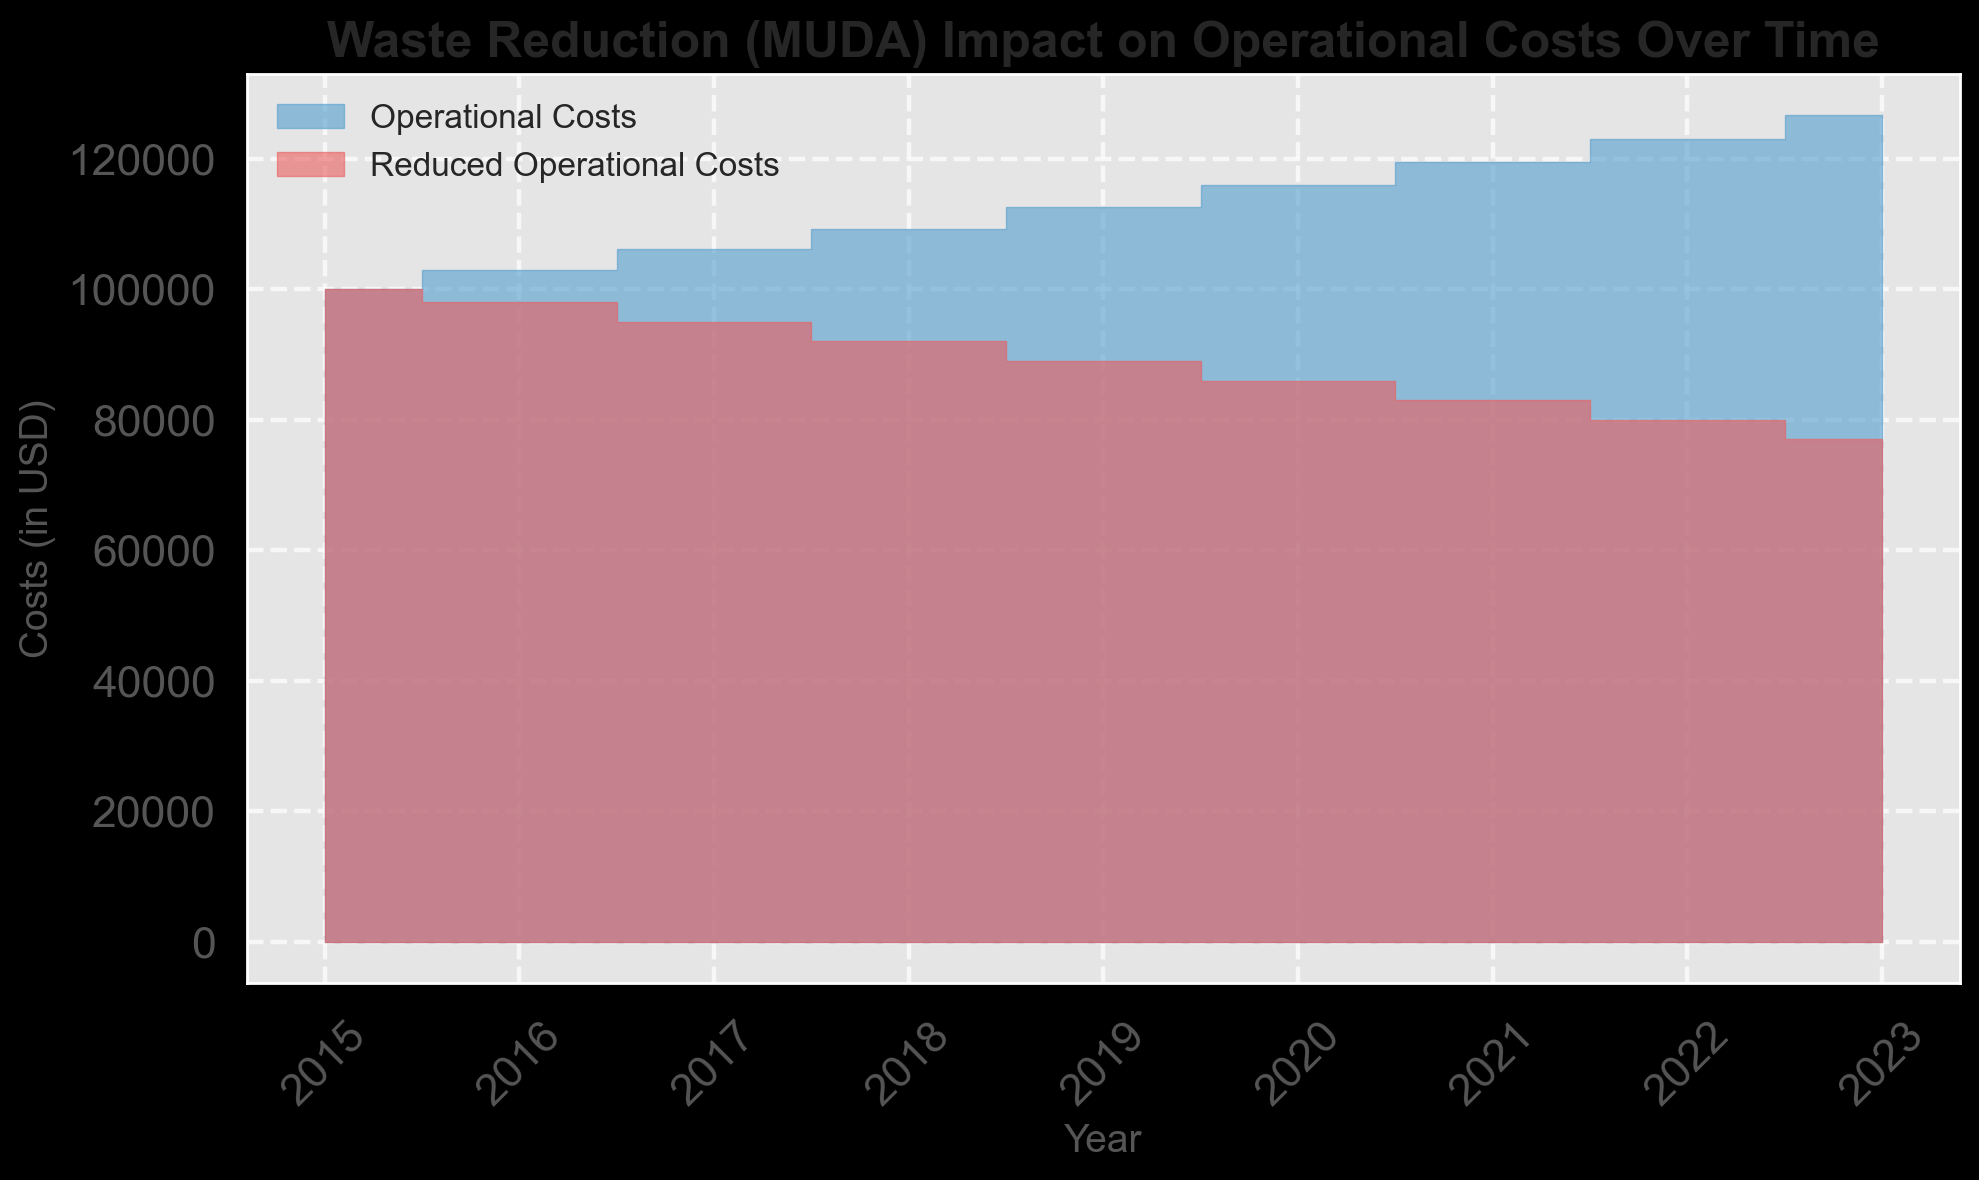What year shows the greatest difference between Operational Costs and Reduced Operational Costs? In the chart, look for the year where the gap between the blue and red areas is the widest. This visual gap represents the difference between the two costs.
Answer: 2023 Between 2015 and 2023, in which year do Operational Costs exceed $110,000? Identify the point where the blue area crosses above the $110,000 mark. Look along the x-axis between 2015 and 2023.
Answer: 2019 During which years do the Reduced Operational Costs trend downward? Observe the red area in the plot and note the years where the height of the red area decreases as time progresses.
Answer: 2016-2023 By how much did the Reduced Operational Costs decrease between 2015 and 2018? Subtract the Reduced Operational Costs in 2018 from those in 2015. The calculation is $100,000 - $92,000, which gives the difference.
Answer: $8,000 What is the average Operational Cost for the years 2020 to 2023? Add the Operational Costs for each year from 2020 to 2023 and then divide by the number of years: (115927 + 119405 + 122987 + 126677) / 4. The sum is $485996, and the average is 485996/4.
Answer: $121,499 Which year experienced the smallest difference between Operational Costs and Reduced Operational Costs? Find the year where the gap between the blue and red areas is the smallest. This indicates the lowest difference between the Operational Costs and Reduced Operational Costs.
Answer: 2015 Compare the trend of Operational Costs and Reduced Operational Costs from 2015 to 2023. Do they always follow a similar or divergent trend? Evaluate if both lines (blue for Operational Costs and red for Reduced Operational Costs) move in the same direction (upward or downward) for each corresponding year or if they diverge.
Answer: Divergent What color represents Reduced Operational Costs in the chart? Analyze the colors used in the area chart and identify the color associated with Reduced Operational Costs.
Answer: Red Is the difference between Operational Costs and Reduced Operational Costs greater in 2019 or 2020? Calculate the difference for each year by subtracting Reduced Operational Costs from Operational Costs in 2019 ($112,551 - $89,000) and 2020 ($115,927 - $86,000), then compare the two results.
Answer: 2020 